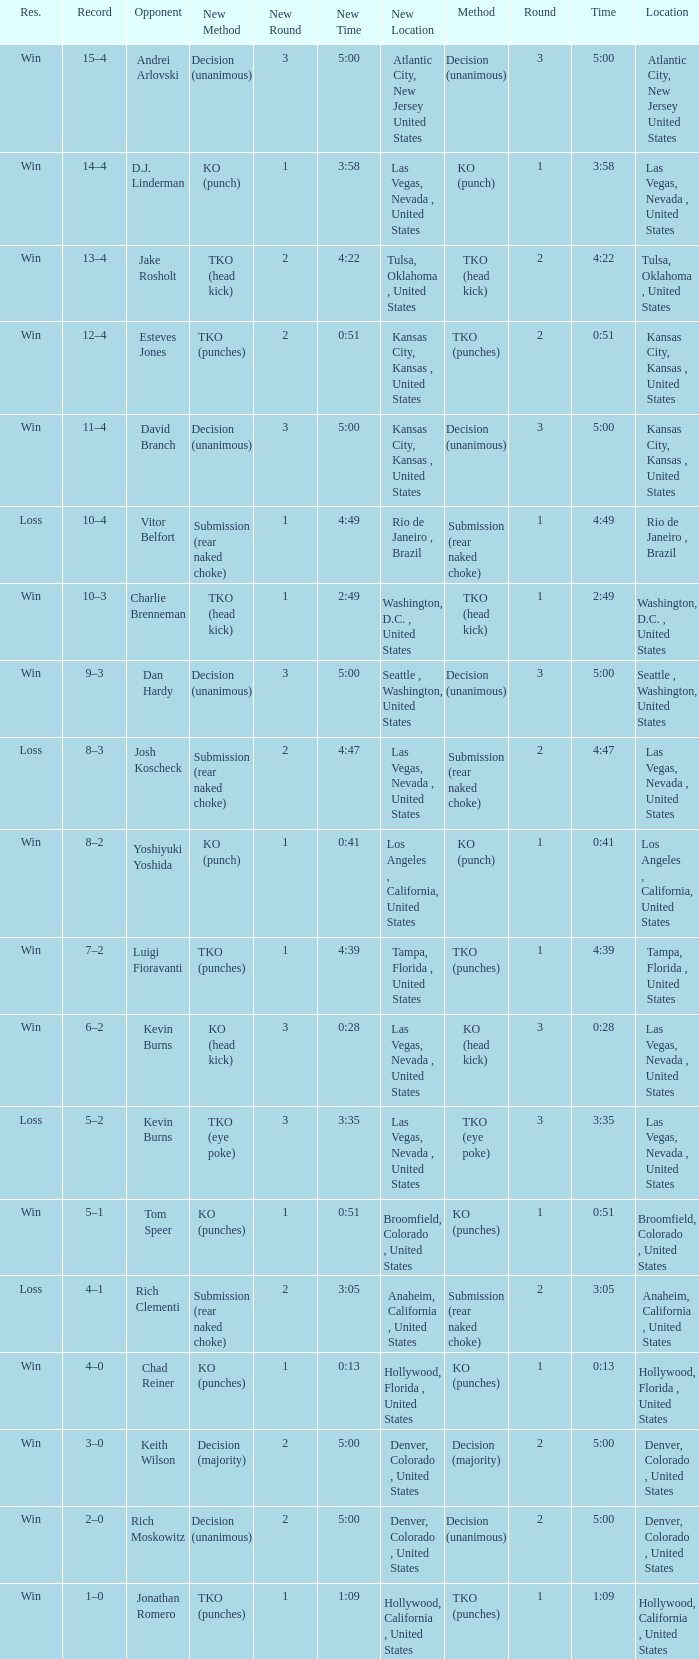What is the result for rounds under 2 against D.J. Linderman? Win. 